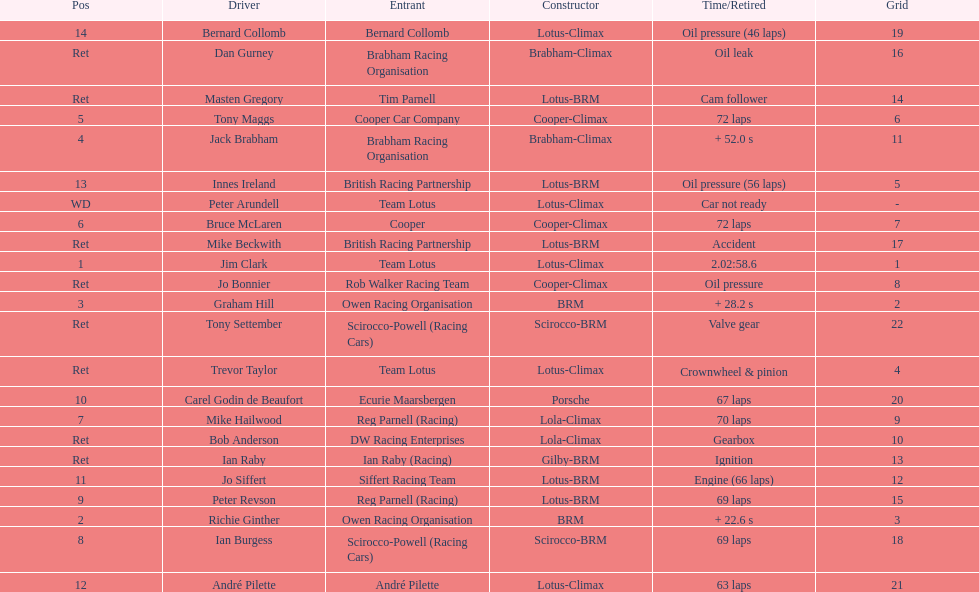Who came in first? Jim Clark. 